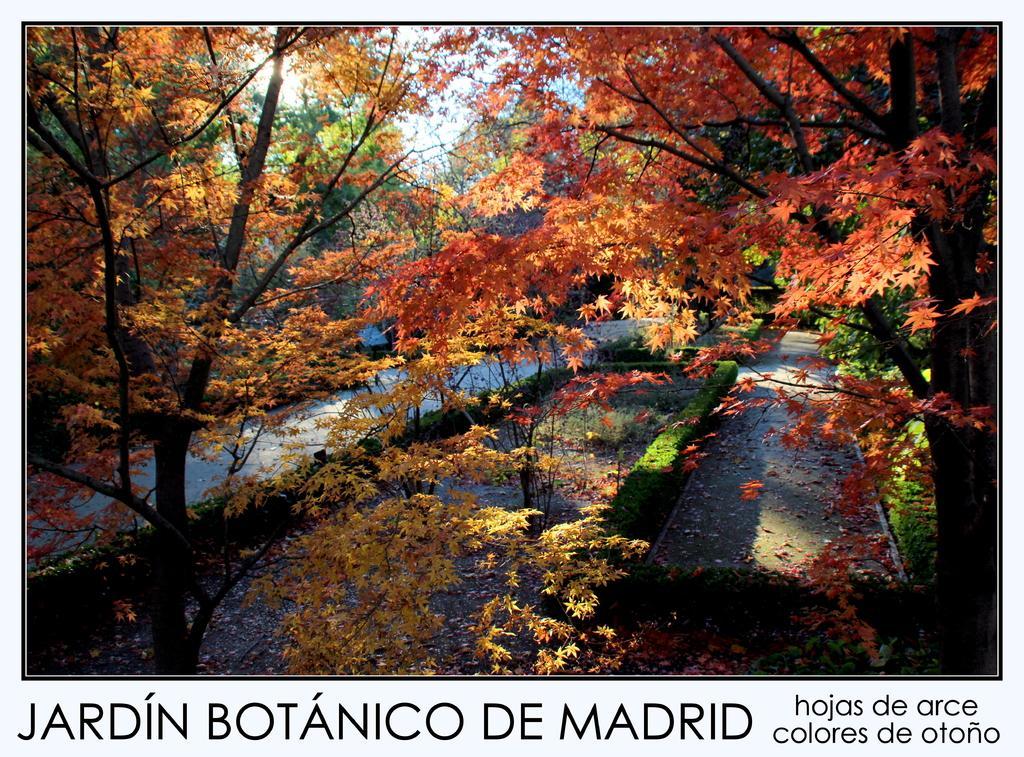Can you describe this image briefly? It is a poster. In this image, we can see so many trees, plants, grass and road. At the bottom of the image, we can see some text. 